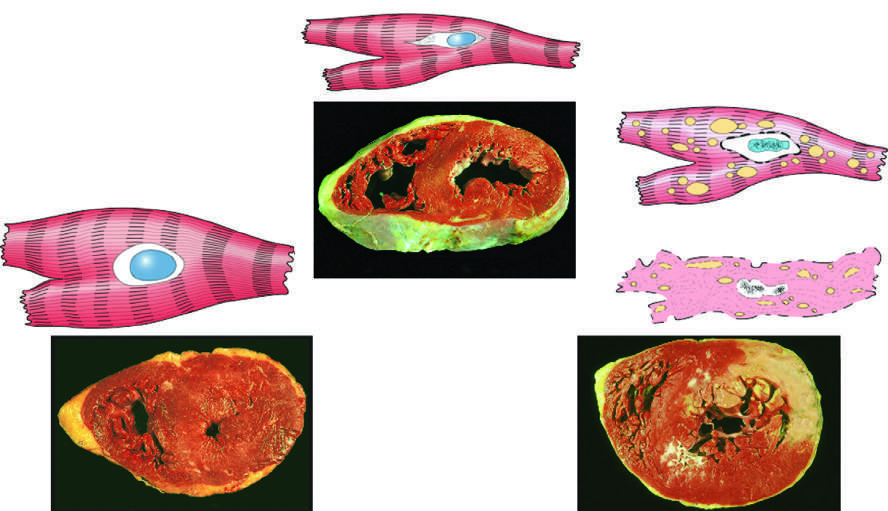what is ischemic coagulative necrosis?
Answer the question using a single word or phrase. The irreversible injury 